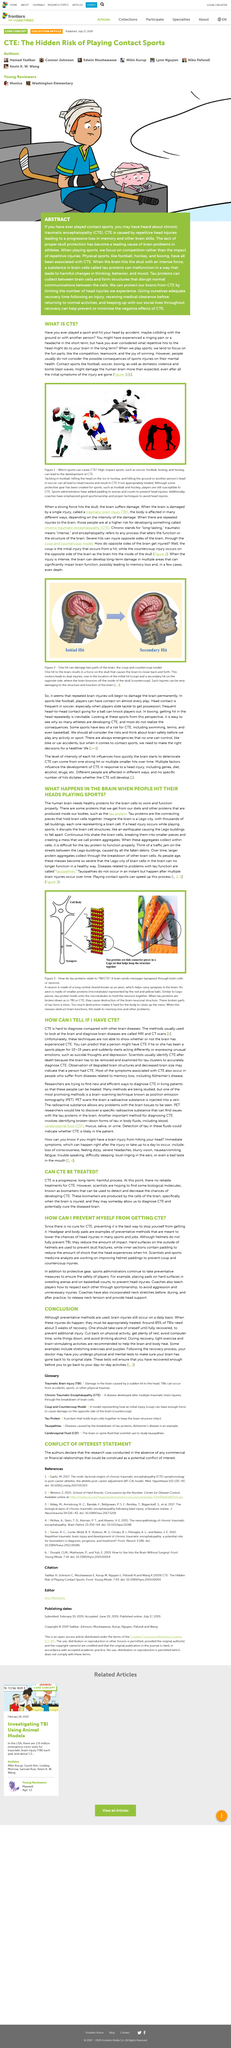Outline some significant characteristics in this image. Sport administrators have made significant contributions to arenas by adding critical safety features, such as padding, to enhance the well-being of athletes and spectators. Contact sports are soccer, football, boxing, and hockey, which involve physical contact between players. To prevent head injuries among athletes, sport administrators have implemented measures such as the use of pads on hard surfaces in wrestling arenas and on basketball courts. Contrary to popular belief, helmets do not fully prevent traumatic brain injuries (TBIs), but rather reduce the impact of such injuries. Magnetic Resonance Imaging (MRI) and Computed Tomography (CT) scans are typically employed to diagnose brain diseases. 